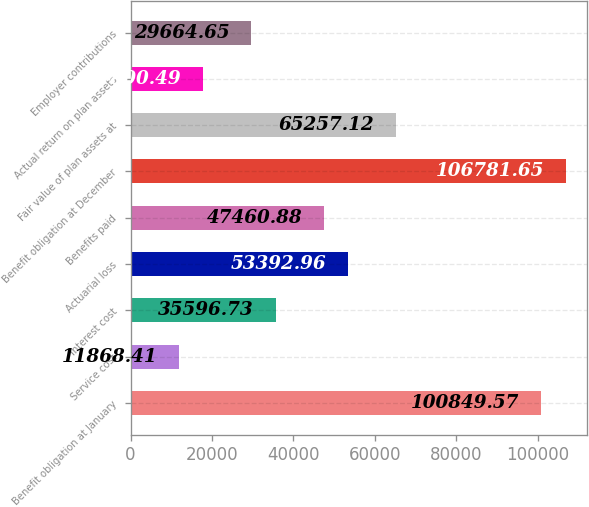Convert chart. <chart><loc_0><loc_0><loc_500><loc_500><bar_chart><fcel>Benefit obligation at January<fcel>Service cost<fcel>Interest cost<fcel>Actuarial loss<fcel>Benefits paid<fcel>Benefit obligation at December<fcel>Fair value of plan assets at<fcel>Actual return on plan assets<fcel>Employer contributions<nl><fcel>100850<fcel>11868.4<fcel>35596.7<fcel>53393<fcel>47460.9<fcel>106782<fcel>65257.1<fcel>17800.5<fcel>29664.7<nl></chart> 